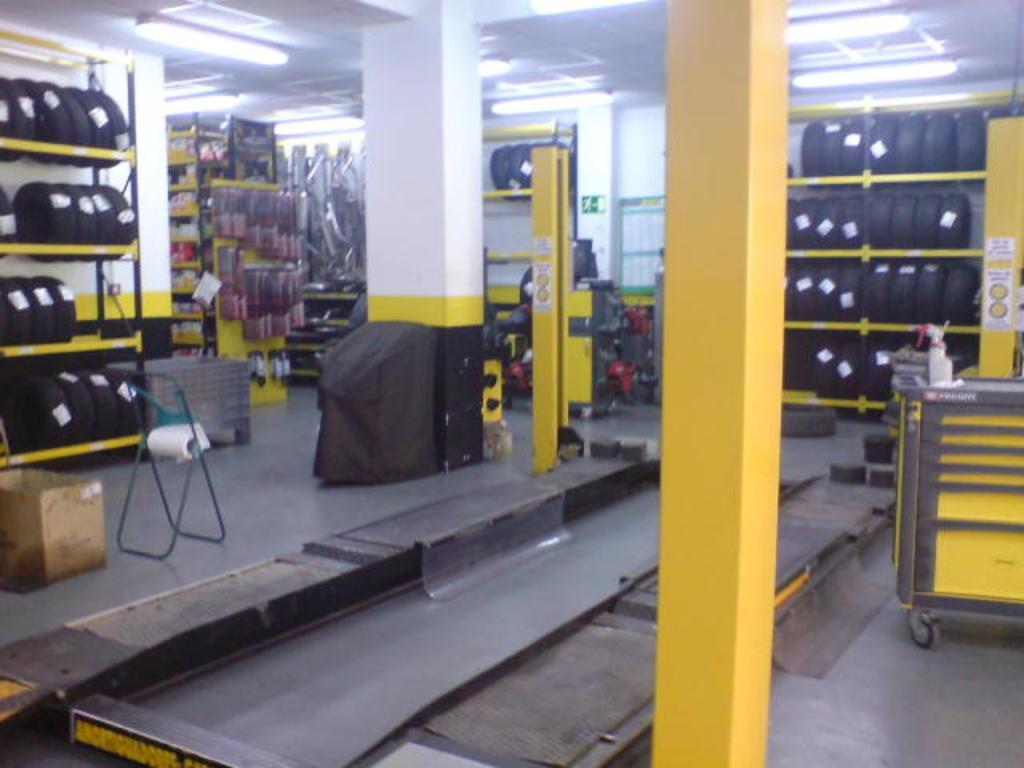Please provide a concise description of this image. We can see card board box,box,cart,black object and chair on the floor and we can see bottle on the cart. We can see tires in racks. In the background we can see objects in racks. At the top we can see lights. 